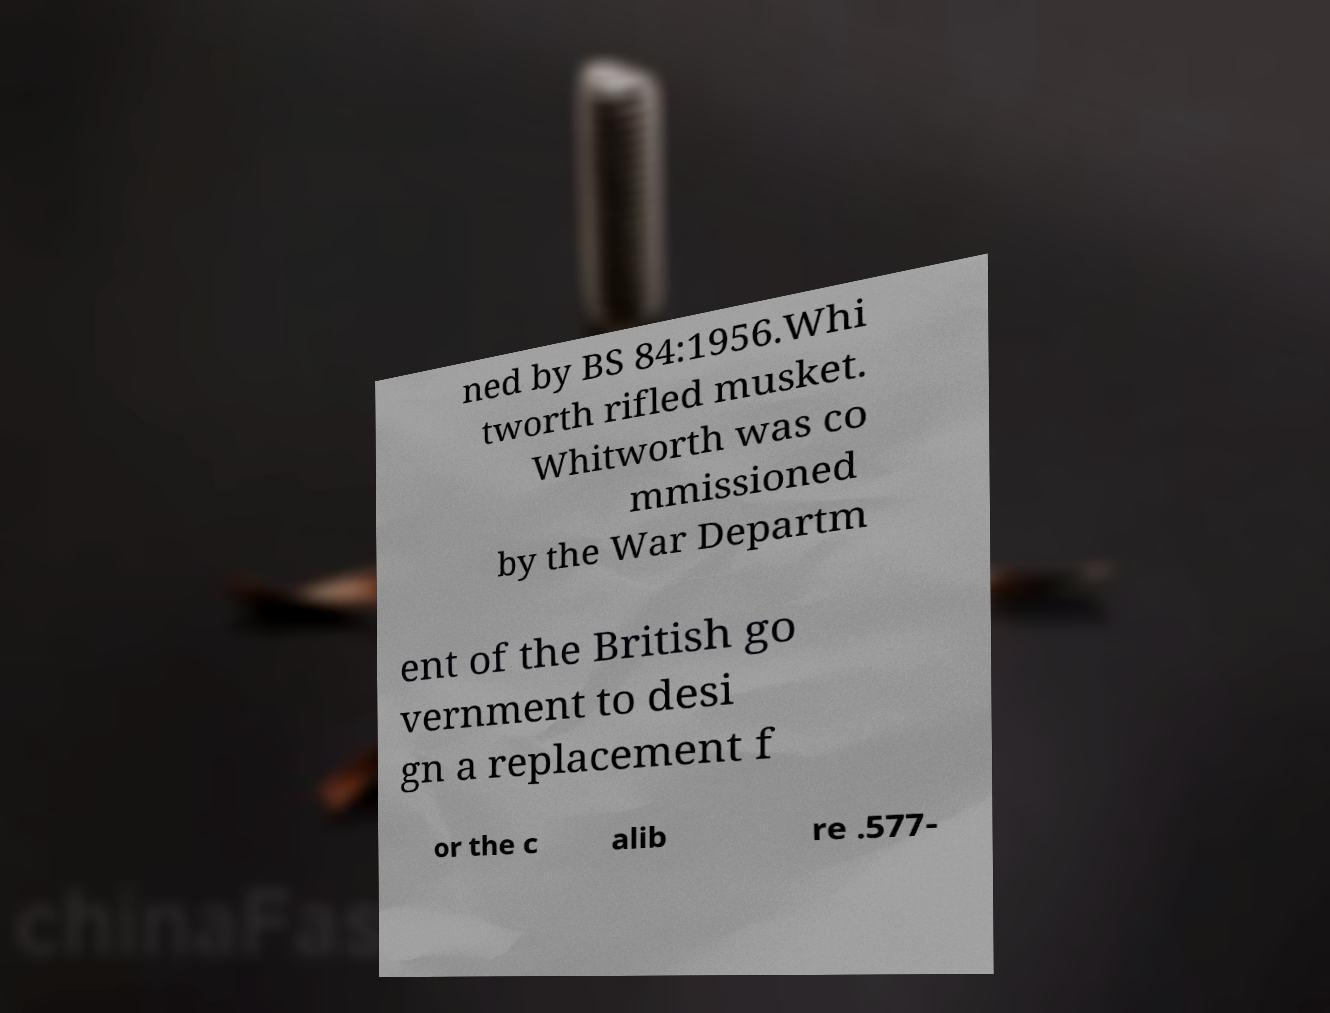Please identify and transcribe the text found in this image. ned by BS 84:1956.Whi tworth rifled musket. Whitworth was co mmissioned by the War Departm ent of the British go vernment to desi gn a replacement f or the c alib re .577- 